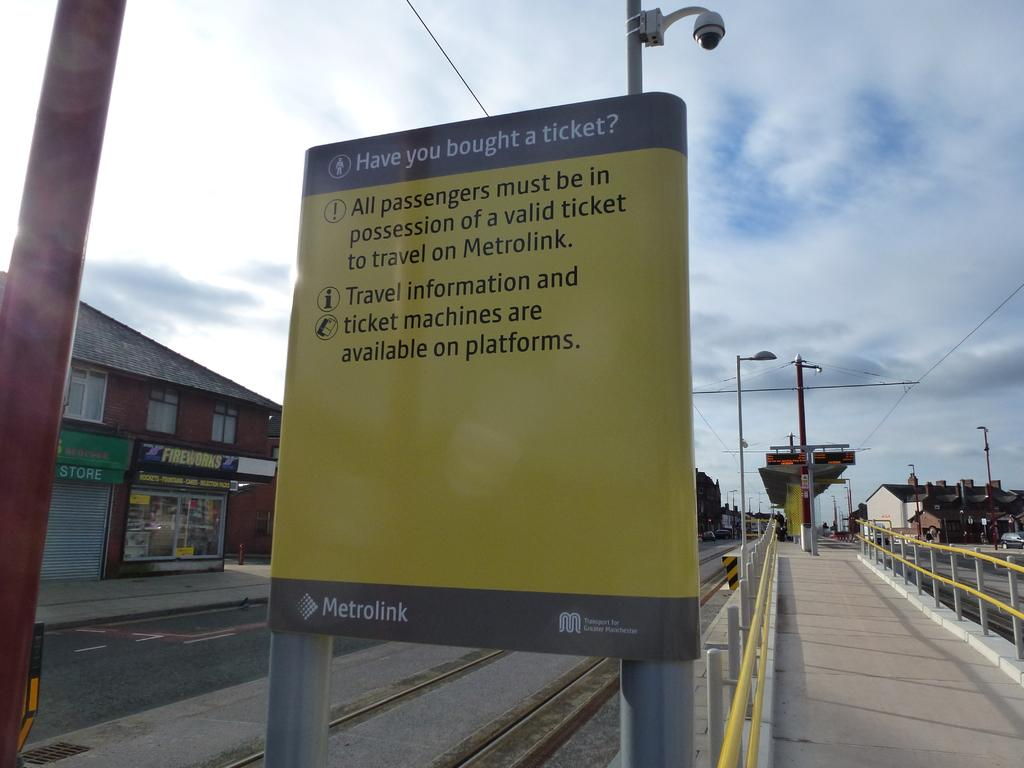Provide a one-sentence caption for the provided image. Metrolink has a sign displayed about their ticket information. 